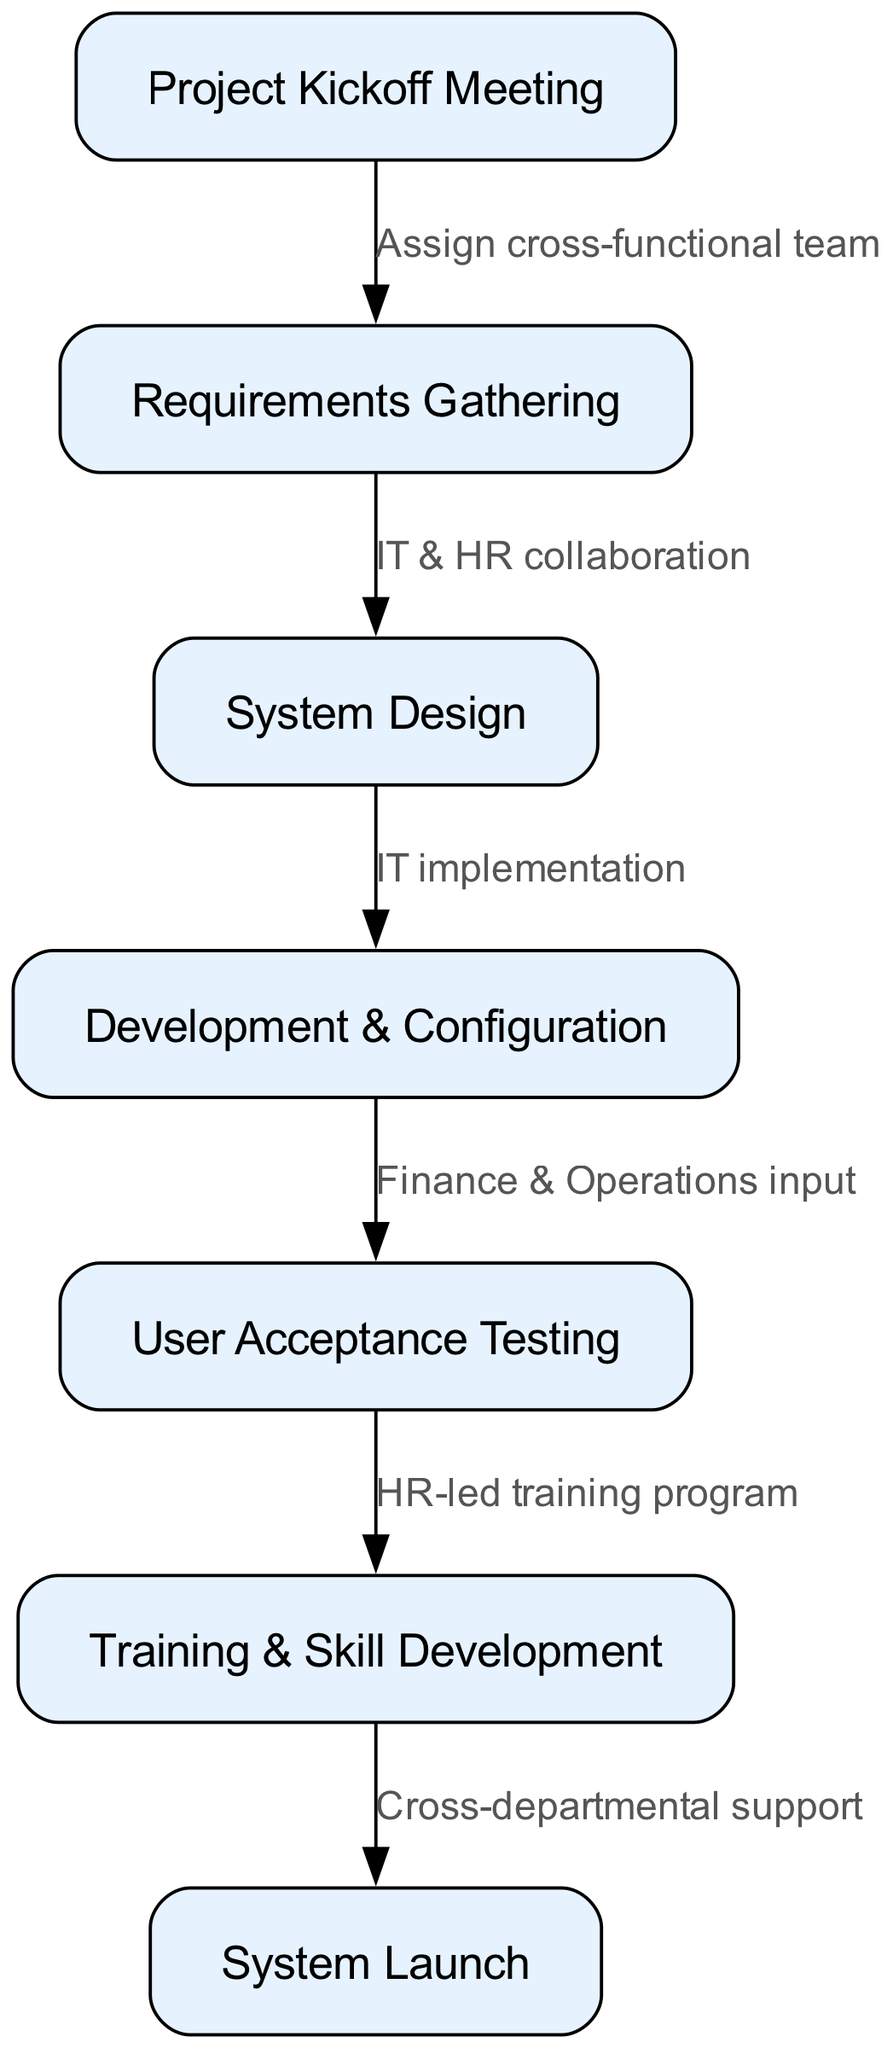What is the title of the diagram? The title of the diagram is provided at the beginning of the data, indicating the focus on interdepartmental collaboration for HR system implementation.
Answer: Interdepartmental Collaboration for HR System Implementation How many nodes are present in the diagram? By counting the nodes listed in the data, there are 7 distinct steps in the process of HR system implementation depicted in the diagram.
Answer: 7 What is the action between the "Project Kickoff Meeting" and "Requirements Gathering"? The relationship between these two nodes is indicated by the labeled edge connecting them, specifying that a cross-functional team is assigned during this transition.
Answer: Assign cross-functional team Which department collaborates with HR during "Requirements Gathering"? The edge from "Requirements Gathering" to "System Design" indicates that IT collaborates with HR in this phase, as noted in the label.
Answer: IT What input is provided during the transition from "Development & Configuration" to "User Acceptance Testing"? The edge connecting these two nodes states that input is provided by Finance and Operations, highlighting their role during this phase.
Answer: Finance & Operations input What is emphasized in the final transition to the "System Launch"? The edge from "Training & Skill Development" to "System Launch" indicates the importance of cross-departmental support in successfully launching the system.
Answer: Cross-departmental support What is the central focus of the "Training & Skill Development" node? This node captures the essence of enhancing employee capabilities and knowledge through a dedicated HR-led training program, preparing the workforce for the new system.
Answer: HR-led training program Which node precedes the "System Launch"? The flow of the diagram indicates that "Training & Skill Development" occurs immediately before the "System Launch," confirming the sequential nature of the tasks.
Answer: Training & Skill Development What phase directly follows "User Acceptance Testing"? The consecutive edge from "User Acceptance Testing" leads directly to "Training & Skill Development," which is the next phase in the implementation process.
Answer: Training & Skill Development 